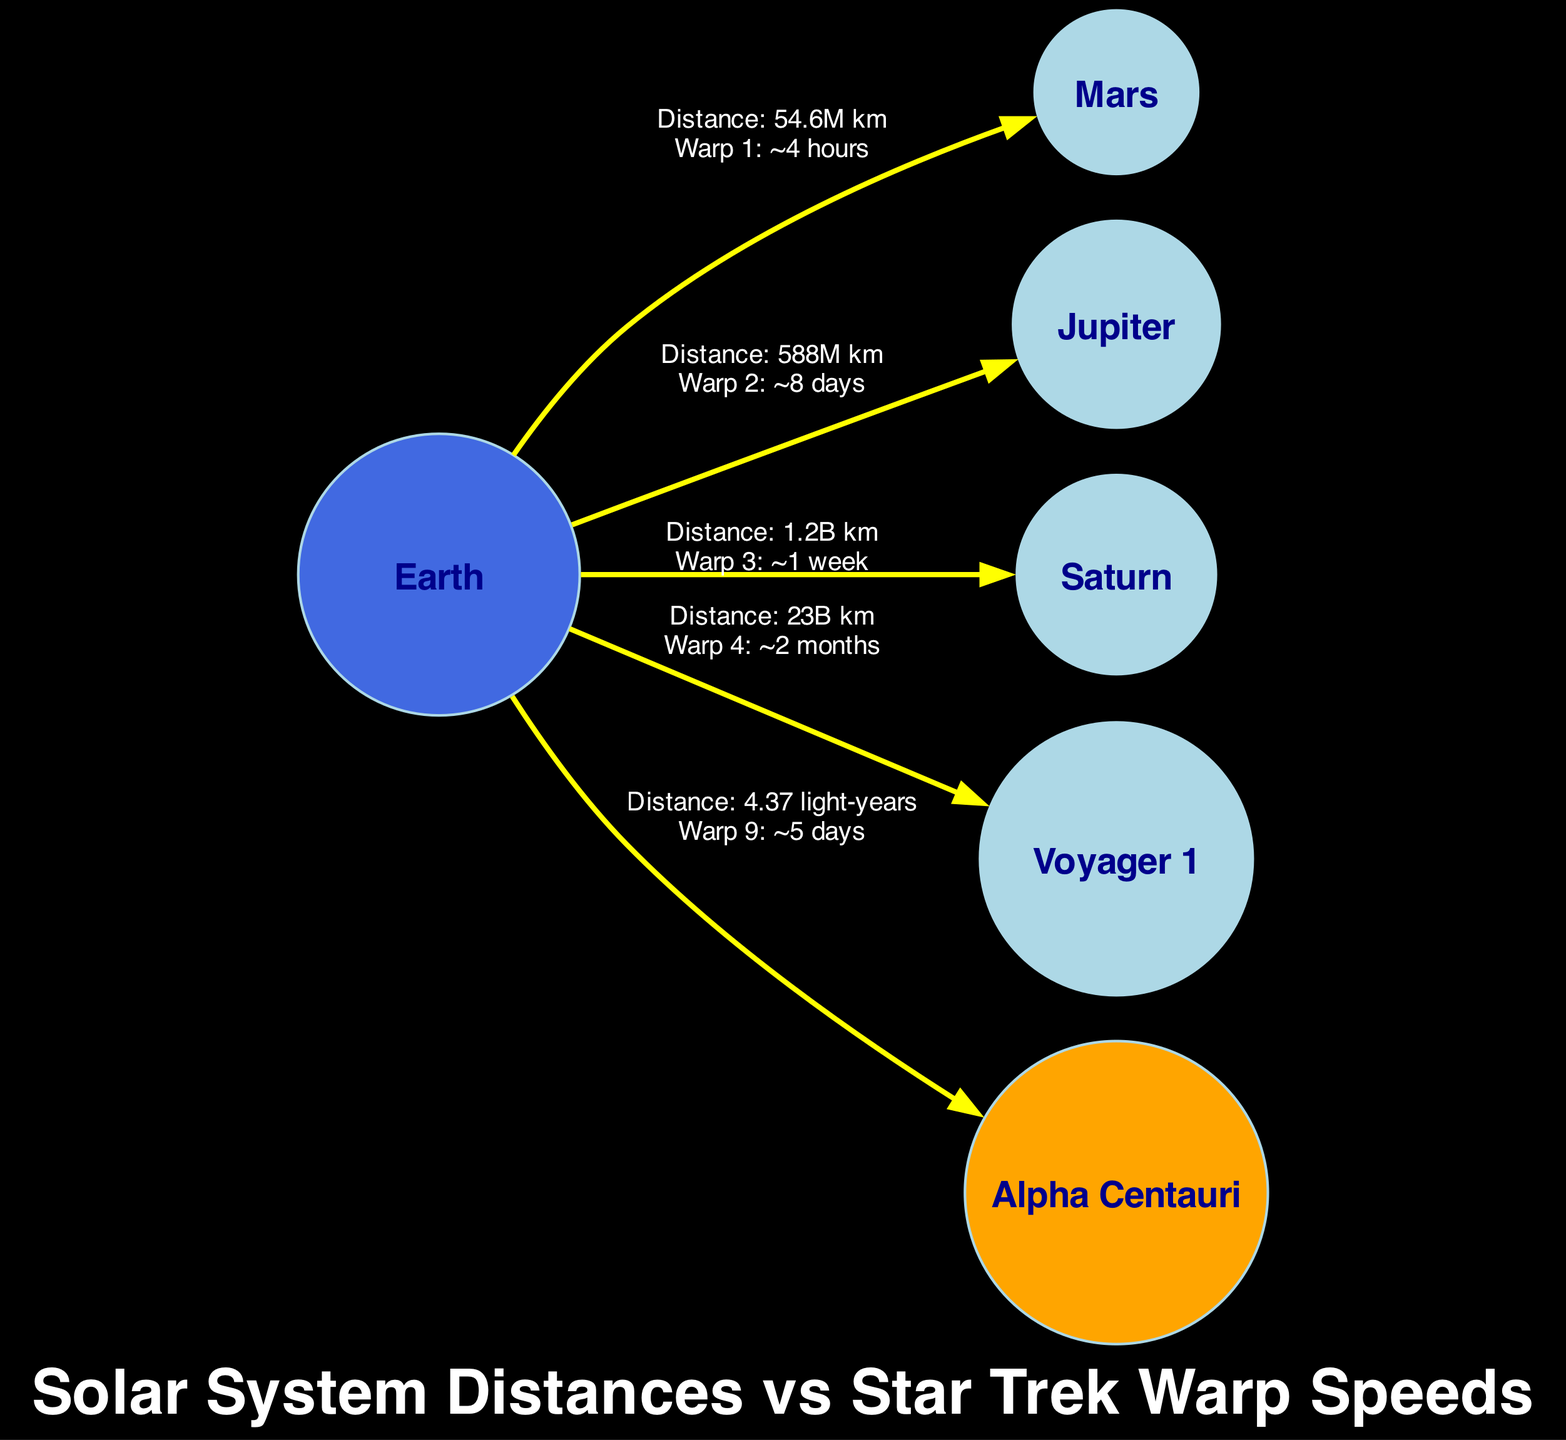What is the distance from Earth to Mars? The diagram indicates a direct connection between Earth and Mars with a label showing "Distance: 54.6M km." Thus, the distance can be directly taken from this label.
Answer: 54.6M km How long would it take to reach Saturn using Warp speed 3? The edge connecting Earth to Saturn shows the label "Warp 3: ~1 week." This label informs us how long it takes to travel this distance using the specified warp speed.
Answer: ~1 week Which celestial body is closest to Earth in this diagram? The closest body to Earth is Mars, as indicated by the direct edge connecting Earth and Mars with the shortest distance of 54.6M km compared to other distances shown in the diagram.
Answer: Mars What is the Warp speed needed to reach Alpha Centauri? The edge from Earth to Alpha Centauri shows the label "Warp 9: ~5 days," specifying the warp speed needed to travel to Alpha Centauri from Earth.
Answer: Warp 9 How many nodes are present in the diagram? Counting the individual nodes listed: Earth, Mars, Jupiter, Saturn, Voyager 1, and Alpha Centauri, there are a total of 6 nodes.
Answer: 6 What is the distance from Earth to Voyager 1? The label on the edge from Earth to Voyager 1 reads "Distance: 23B km," directly providing the necessary distance information from Earth to this spacecraft.
Answer: 23B km Which celestial body would take the longest time to reach from Earth using Warp speed? By comparing the time labels on the edges, the longest time specified is "Warp 4: ~2 months" for Voyager 1. Hence, it takes the longest to reach Voyager 1 from Earth.
Answer: Voyager 1 What is the distance from Earth to Jupiter, and how does it compare with the distance to Saturn? The distance to Jupiter is "Distance: 588M km," and for Saturn, it is "Distance: 1.2B km." Comparing these values shows that the distance to Saturn is greater than to Jupiter, as 1.2B km is larger than 588M km.
Answer: 588M km; distance to Saturn is greater How would Warp speed 3 facilitate travel to all nodes in the diagram? Warp speed 3 allows travel to Jupiter in ~8 days and to Saturn in ~1 week. Other nodes like Mars and Alpha Centauri require different speeds, hence only Jupiter and Saturn could be reached specifically with Warp speed 3 in predetermined times specified in the diagram.
Answer: Travel to Jupiter and Saturn 